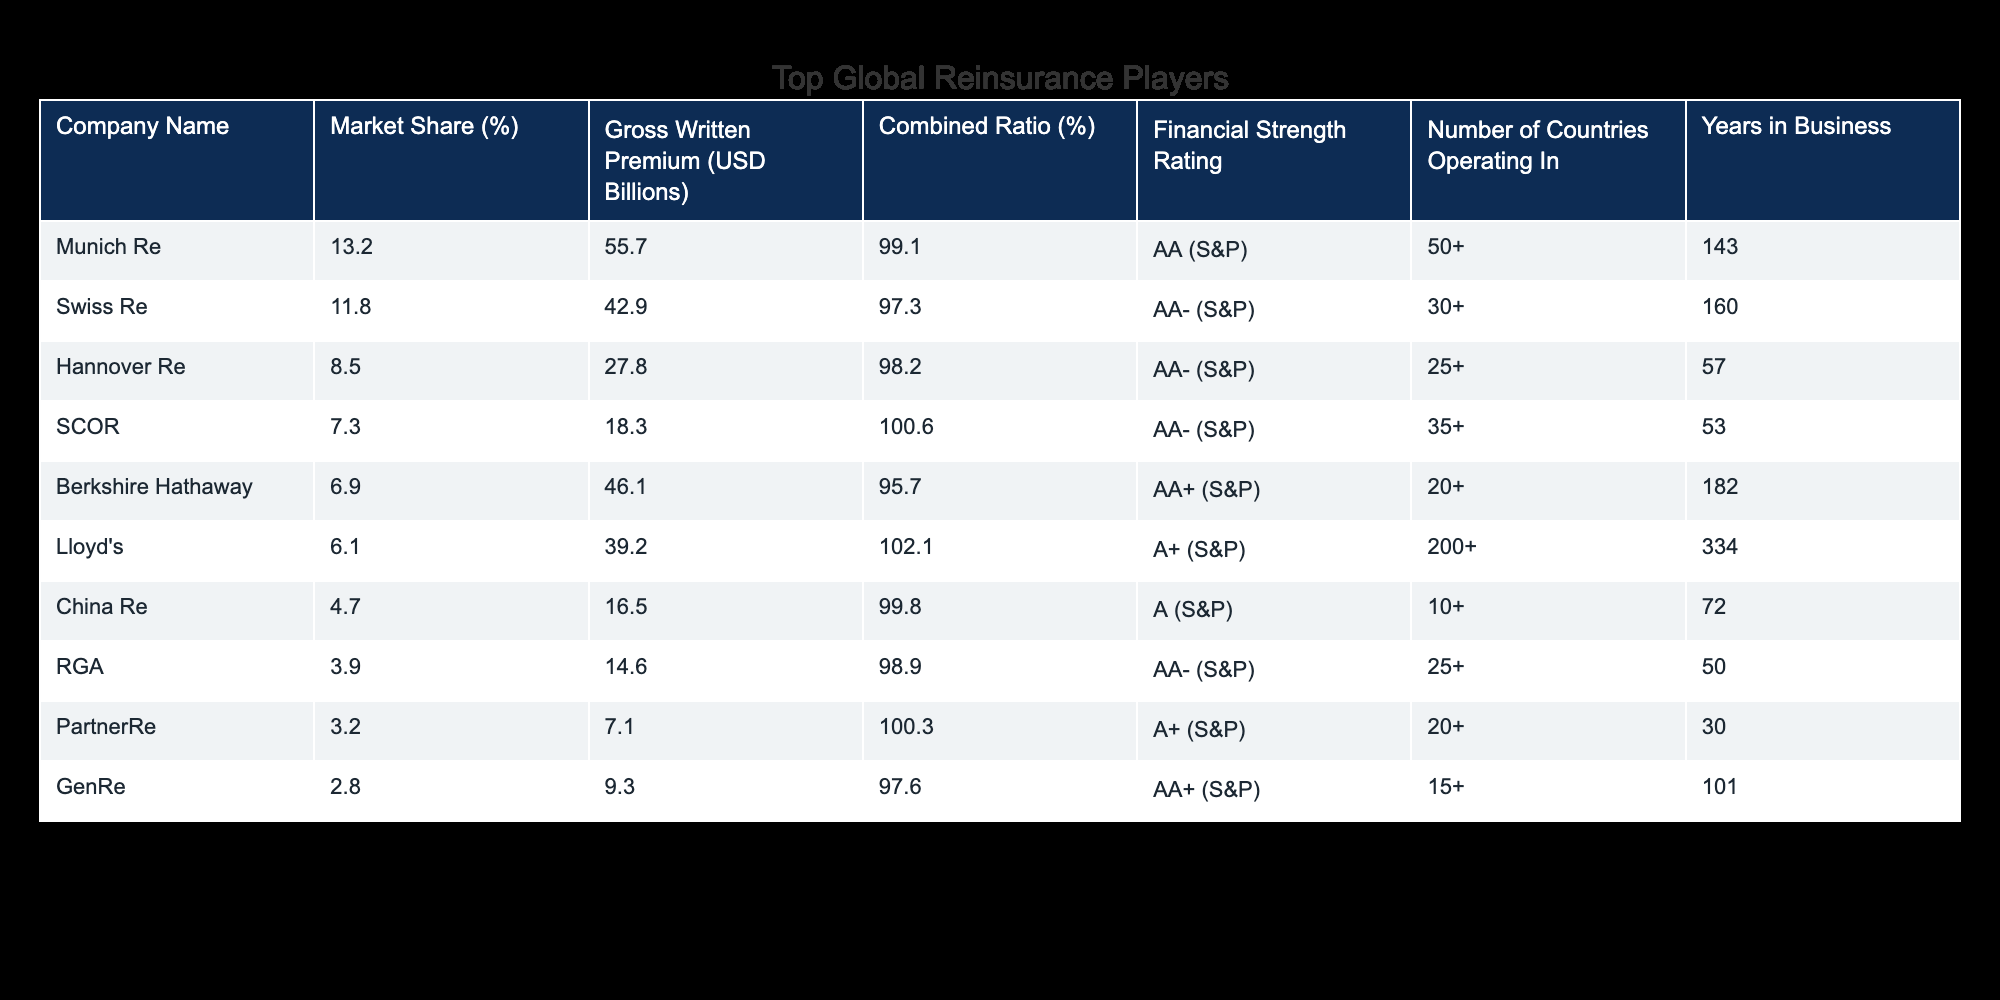What is the market share of Munich Re? The market share for Munich Re is directly listed in the table under the "Market Share (%)" column. The value for Munich Re is 13.2%.
Answer: 13.2% Which company has the highest gross written premium? To find this, we look at the "Gross Written Premium (USD Billions)" column and identify the company with the highest value. Munich Re has the highest gross written premium at 55.7 billion USD.
Answer: 55.7 What is the combined ratio of Swiss Re? The combined ratio for Swiss Re is also directly stated in the table. Referring to the "Combined Ratio (%)" column for Swiss Re, we find it to be 97.3%.
Answer: 97.3% Is SCOR rated higher than China Re financially? We compare the financial strength ratings for both SCOR and China Re in the "Financial Strength Rating" column. SCOR has an AA- rating, while China Re has an A rating, indicating SCOR is rated higher.
Answer: Yes What is the average market share of the top three companies? To calculate the average, we sum the market shares of the top three companies: 13.2% (Munich Re) + 11.8% (Swiss Re) + 8.5% (Hannover Re) = 33.5%. Then, we divide by 3 to get the average: 33.5% / 3 = 11.17%.
Answer: 11.17% How many countries are operated by the company with the lowest market share? The company with the lowest market share is GenRe, with a market share of 2.8%. Referring to the "Number of Countries Operating In" column, GenRe operates in 15 countries.
Answer: 15 What is the difference in combined ratio between Berkshire Hathaway and PartnerRe? To find the difference, we subtract PartnerRe's combined ratio (100.3%) from Berkshire Hathaway's combined ratio (95.7%): 100.3% - 95.7% = 4.6%.
Answer: 4.6% How many years has Hannover Re been in business compared to RGA? Referring to the "Years in Business" column, Hannover Re has been in business for 57 years while RGA has been in business for 50 years. Therefore, Hannover Re has been in business 7 years longer than RGA.
Answer: 7 years Does any company have a combined ratio below 98%? We check the "Combined Ratio (%)" column to see if any values are below 98%. Munich Re (99.1%), SCOR (100.6%), and Lloyd's (102.1%) are above 98%, but Swiss Re (97.3%) has a combined ratio below that threshold.
Answer: Yes 